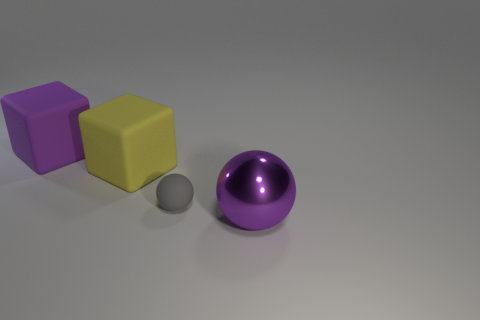Add 2 tiny gray blocks. How many objects exist? 6 Add 3 large yellow rubber things. How many large yellow rubber things exist? 4 Subtract 0 red cylinders. How many objects are left? 4 Subtract all purple spheres. Subtract all gray things. How many objects are left? 2 Add 3 matte blocks. How many matte blocks are left? 5 